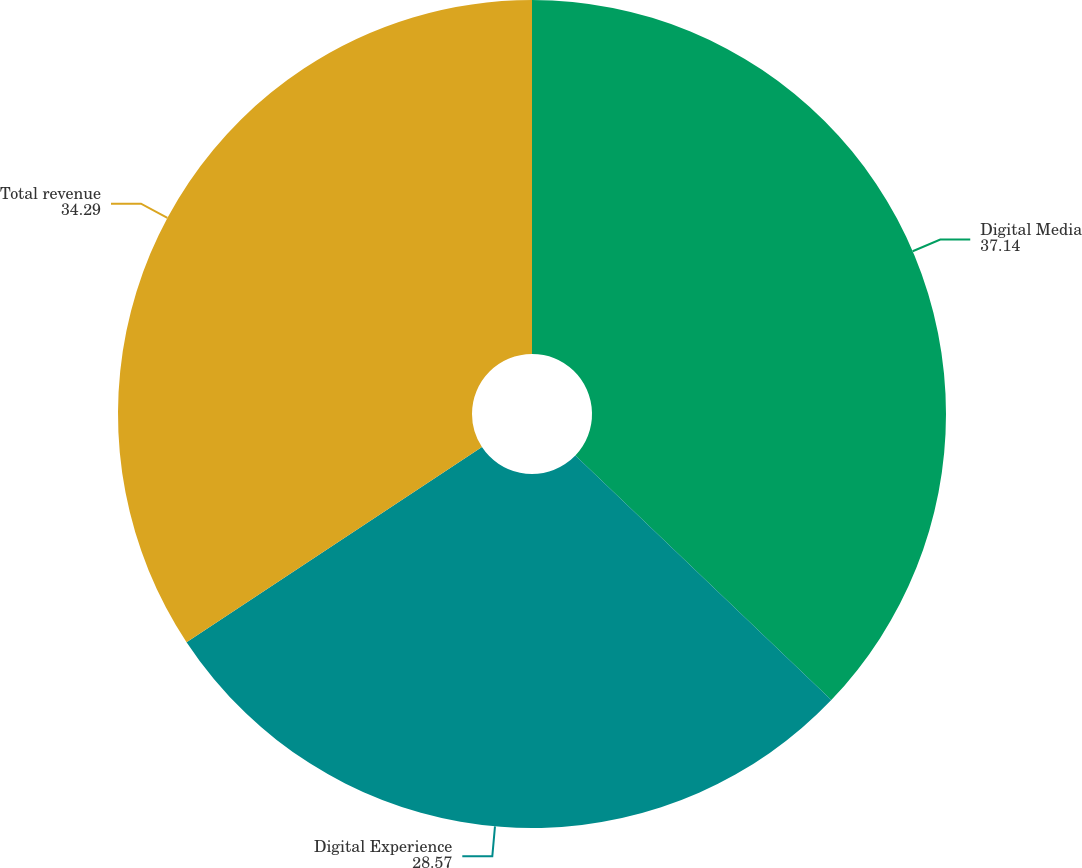Convert chart. <chart><loc_0><loc_0><loc_500><loc_500><pie_chart><fcel>Digital Media<fcel>Digital Experience<fcel>Total revenue<nl><fcel>37.14%<fcel>28.57%<fcel>34.29%<nl></chart> 